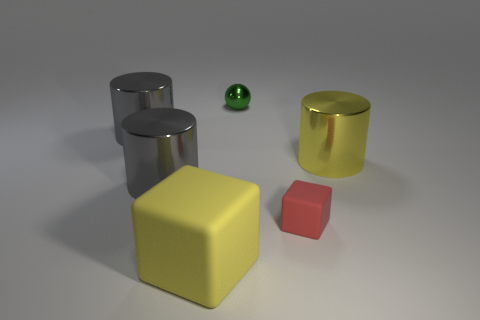What is the sphere made of?
Your answer should be compact. Metal. Is the number of cylinders that are on the left side of the big yellow shiny object greater than the number of red cubes?
Offer a terse response. Yes. Are there any blue matte blocks?
Provide a short and direct response. No. How many other things are there of the same shape as the large rubber thing?
Provide a succinct answer. 1. There is a matte thing in front of the small red rubber thing; is its color the same as the cylinder right of the red object?
Your answer should be very brief. Yes. How big is the shiny cylinder to the right of the block that is in front of the block that is right of the tiny shiny object?
Keep it short and to the point. Large. What shape is the shiny object that is behind the yellow cylinder and on the left side of the big yellow block?
Keep it short and to the point. Cylinder. Are there the same number of small metallic objects on the right side of the small red matte block and gray objects that are on the right side of the yellow cylinder?
Provide a short and direct response. Yes. Is there a big cube made of the same material as the small red object?
Provide a succinct answer. Yes. Are the yellow thing on the left side of the tiny green ball and the tiny red object made of the same material?
Your answer should be very brief. Yes. 